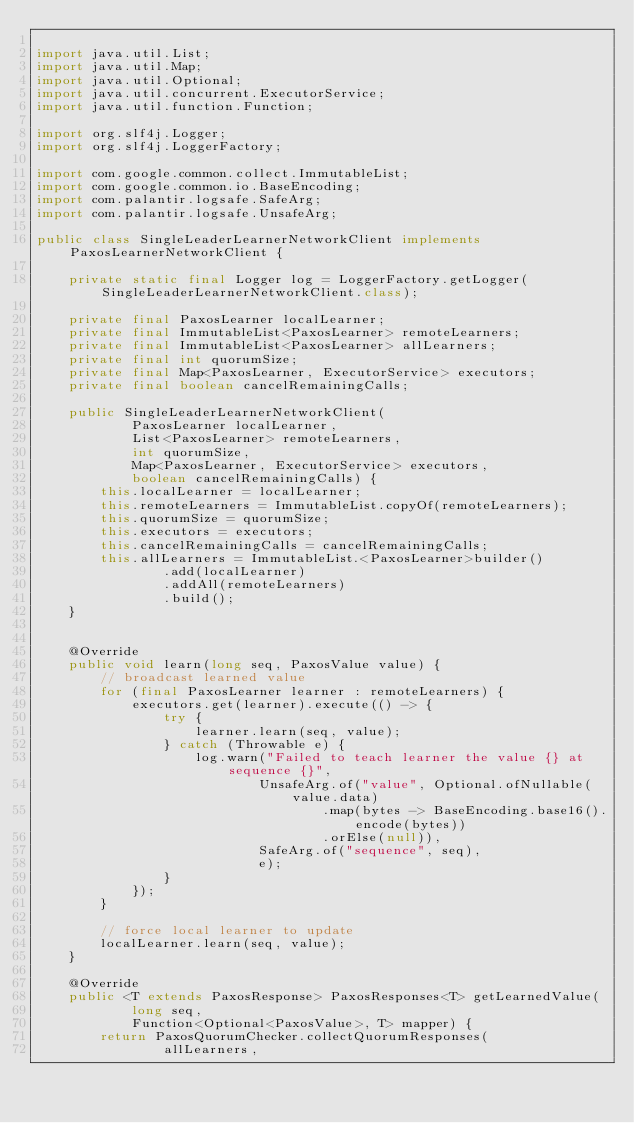Convert code to text. <code><loc_0><loc_0><loc_500><loc_500><_Java_>
import java.util.List;
import java.util.Map;
import java.util.Optional;
import java.util.concurrent.ExecutorService;
import java.util.function.Function;

import org.slf4j.Logger;
import org.slf4j.LoggerFactory;

import com.google.common.collect.ImmutableList;
import com.google.common.io.BaseEncoding;
import com.palantir.logsafe.SafeArg;
import com.palantir.logsafe.UnsafeArg;

public class SingleLeaderLearnerNetworkClient implements PaxosLearnerNetworkClient {

    private static final Logger log = LoggerFactory.getLogger(SingleLeaderLearnerNetworkClient.class);

    private final PaxosLearner localLearner;
    private final ImmutableList<PaxosLearner> remoteLearners;
    private final ImmutableList<PaxosLearner> allLearners;
    private final int quorumSize;
    private final Map<PaxosLearner, ExecutorService> executors;
    private final boolean cancelRemainingCalls;

    public SingleLeaderLearnerNetworkClient(
            PaxosLearner localLearner,
            List<PaxosLearner> remoteLearners,
            int quorumSize,
            Map<PaxosLearner, ExecutorService> executors,
            boolean cancelRemainingCalls) {
        this.localLearner = localLearner;
        this.remoteLearners = ImmutableList.copyOf(remoteLearners);
        this.quorumSize = quorumSize;
        this.executors = executors;
        this.cancelRemainingCalls = cancelRemainingCalls;
        this.allLearners = ImmutableList.<PaxosLearner>builder()
                .add(localLearner)
                .addAll(remoteLearners)
                .build();
    }


    @Override
    public void learn(long seq, PaxosValue value) {
        // broadcast learned value
        for (final PaxosLearner learner : remoteLearners) {
            executors.get(learner).execute(() -> {
                try {
                    learner.learn(seq, value);
                } catch (Throwable e) {
                    log.warn("Failed to teach learner the value {} at sequence {}",
                            UnsafeArg.of("value", Optional.ofNullable(value.data)
                                    .map(bytes -> BaseEncoding.base16().encode(bytes))
                                    .orElse(null)),
                            SafeArg.of("sequence", seq),
                            e);
                }
            });
        }

        // force local learner to update
        localLearner.learn(seq, value);
    }

    @Override
    public <T extends PaxosResponse> PaxosResponses<T> getLearnedValue(
            long seq,
            Function<Optional<PaxosValue>, T> mapper) {
        return PaxosQuorumChecker.collectQuorumResponses(
                allLearners,</code> 